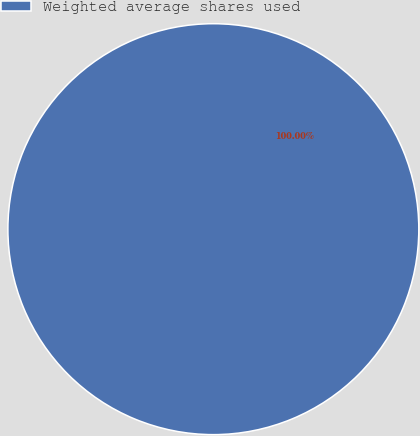Convert chart. <chart><loc_0><loc_0><loc_500><loc_500><pie_chart><fcel>Weighted average shares used<nl><fcel>100.0%<nl></chart> 